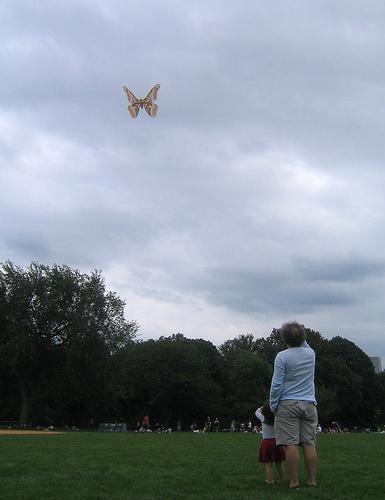How many kites are there?
Give a very brief answer. 1. 